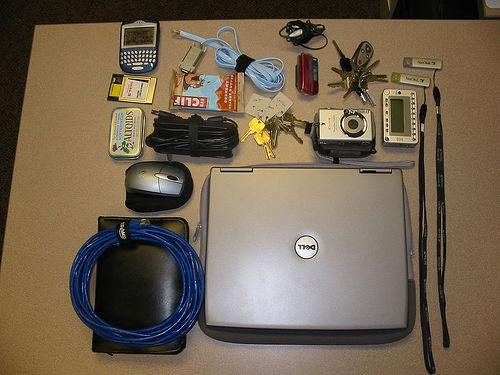In the image, describe what is placed beside the Dell laptop. A small grey colored computer mouse is placed beside the Dell laptop on the table. Describe the image primarily focusing on technological items. The image includes a silver Dell laptop, a wireless mouse, a blue BlackBerry cellphone, and a silver camera on a table. Mention a peculiar item from the image. A gold set of keys is placed on the table. Mention a notable electronic item from the image. A silver Dell laptop placed on the table. What kind of candy is visible in the image? A can of Altoids candy is visible in the image. Highlight a small accessory or item from the image. There are two silver flash drives on lanyards. Identify a type of food or snack present in the image. A Clif energy bar is placed on the table. List three objects that are visible in the image. A dell company laptop, blue colored wire roll, and a leather covered black book. What kind of wire or cable is visible in the image? A rolled-up blue flat cable is visible in the image. Name an office supply in the image and describe it briefly. A blue and silver calculator is lying on the table. 